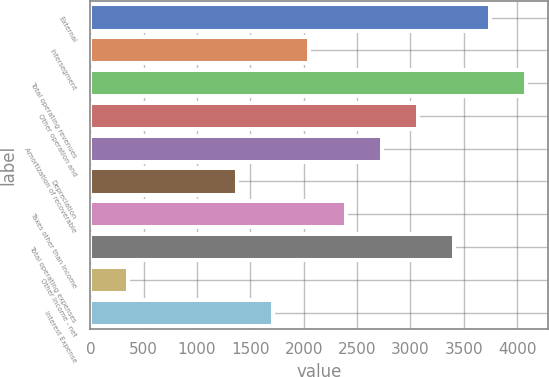Convert chart to OTSL. <chart><loc_0><loc_0><loc_500><loc_500><bar_chart><fcel>External<fcel>Intersegment<fcel>Total operating revenues<fcel>Other operation and<fcel>Amortization of recoverable<fcel>Depreciation<fcel>Taxes other than income<fcel>Total operating expenses<fcel>Other Income - net<fcel>Interest Expense<nl><fcel>3749.2<fcel>2053.2<fcel>4088.4<fcel>3070.8<fcel>2731.6<fcel>1374.8<fcel>2392.4<fcel>3410<fcel>357.2<fcel>1714<nl></chart> 